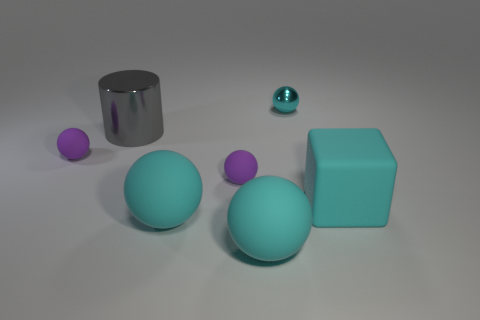How many cylinders are the same size as the cyan rubber cube?
Provide a succinct answer. 1. What material is the cyan cube?
Make the answer very short. Rubber. There is a cyan block; are there any purple spheres behind it?
Your answer should be very brief. Yes. There is a cyan ball that is made of the same material as the cylinder; what is its size?
Keep it short and to the point. Small. How many big objects have the same color as the big cylinder?
Keep it short and to the point. 0. Is the number of big rubber things behind the big cyan block less than the number of spheres that are in front of the gray metal object?
Offer a terse response. Yes. What size is the rubber thing that is right of the cyan metallic ball?
Your response must be concise. Large. There is a rubber cube that is the same color as the small shiny ball; what size is it?
Your answer should be very brief. Large. Are there any small cyan things made of the same material as the block?
Your answer should be compact. No. Are the big cyan cube and the large cylinder made of the same material?
Offer a very short reply. No. 